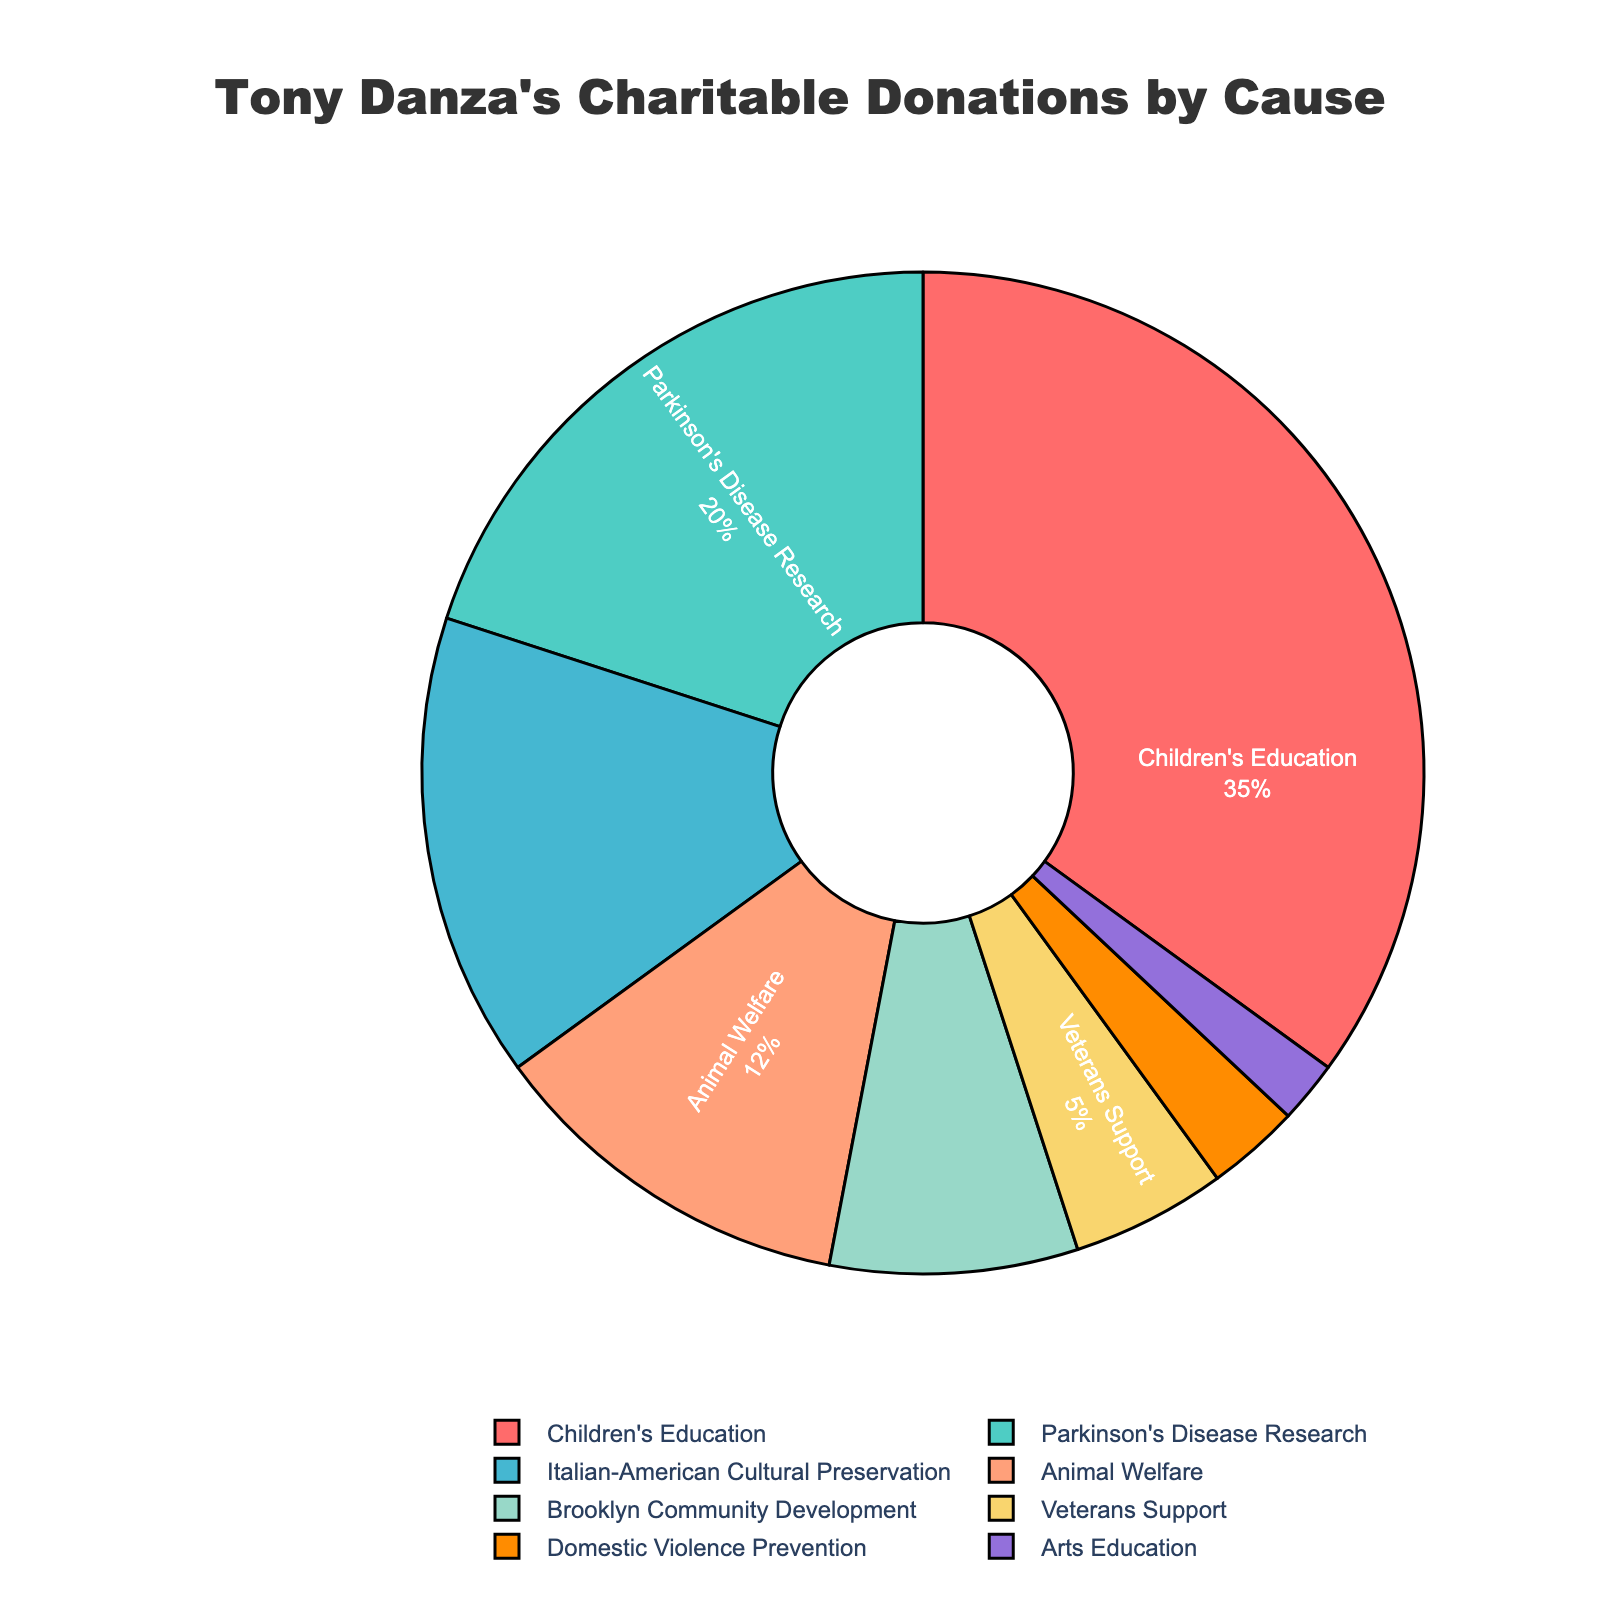Which cause receives the highest percentage of Tony Danza's charitable donations? The figure indicates the percentage of donations by cause. The highest percentage is given to Children's Education.
Answer: Children's Education Which two causes combined make up 27% of Tony Danza's charitable donations? We need to find causes whose percentages add up to 27%. Animal Welfare (12%) combined with Domestic Violence Prevention (3%), and Arts Education (2%), i.e., 12% + 8% + 5% = 27%.
Answer: Animal Welfare and Brooklyn Community Development How much greater is the percentage of donations to Children's Education compared to Veterans Support? Subtract the percentage for Veterans Support from Children's Education. That is, 35% - 5% = 30%.
Answer: 30% What is the total percentage allocated to causes related to health (Parkinson's Disease Research and Domestic Violence Prevention)? Sum the percentages for Parkinson's Disease Research and Domestic Violence Prevention. That is, 20% + 3% = 23%.
Answer: 23% Which cause receives the least percentage of donations, and what is that percentage? The smallest slice on the pie chart represents Arts Education.
Answer: Arts Education, 2% Are more donations allocated toward cultural preservation or animal welfare? Compare the percentages for Italian-American Cultural Preservation (15%) and Animal Welfare (12%).
Answer: Cultural Preservation Which two causes that together make up exactly 20% of the total donations? Arts Education (2%) and Veterans Support (5%) combined do not make 20%. Next, Domestic Violence Prevention (3%) combined with Veterans Support (5%) combined do not make 20%. But Brooklyn Community Development (8%) plus Animal Welfare (12%) equals 20%.
Answer: Animal Welfare and Brooklyn Community Development Which causes have percentages that, when doubled, exceed or equal 30%? Identify causes where twice their values exceed 30%. Children's Education (35%), Italian-American Cultural Preservation (15%), and Animal Welfare (12%) don't fit the criteria of ≤15%. All other values doubled (thus their highest being less than 15) do. Finally, Parkinson's Disease Research: 20*2=40>30. The others below 15 do too (3, 5, 8).
Answer: Parkinson's Disease Research How many causes receive less than 10% of Tony Danza's charitable donations? Count the slices that represent less than 10%. They are: Arts Education, Domestic Violence Prevention, Veterans Support, and Brooklyn Community Development.
Answer: 4 